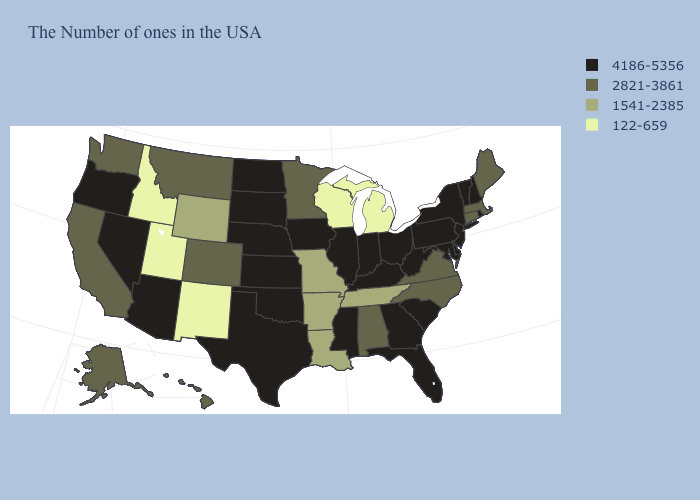Name the states that have a value in the range 122-659?
Write a very short answer. Michigan, Wisconsin, New Mexico, Utah, Idaho. Name the states that have a value in the range 1541-2385?
Give a very brief answer. Tennessee, Louisiana, Missouri, Arkansas, Wyoming. Name the states that have a value in the range 2821-3861?
Be succinct. Maine, Massachusetts, Connecticut, Virginia, North Carolina, Alabama, Minnesota, Colorado, Montana, California, Washington, Alaska, Hawaii. What is the highest value in the USA?
Answer briefly. 4186-5356. Which states have the highest value in the USA?
Quick response, please. Rhode Island, New Hampshire, Vermont, New York, New Jersey, Delaware, Maryland, Pennsylvania, South Carolina, West Virginia, Ohio, Florida, Georgia, Kentucky, Indiana, Illinois, Mississippi, Iowa, Kansas, Nebraska, Oklahoma, Texas, South Dakota, North Dakota, Arizona, Nevada, Oregon. How many symbols are there in the legend?
Answer briefly. 4. Does the map have missing data?
Short answer required. No. Does Pennsylvania have the same value as Utah?
Short answer required. No. How many symbols are there in the legend?
Be succinct. 4. What is the value of Hawaii?
Short answer required. 2821-3861. What is the value of Wisconsin?
Write a very short answer. 122-659. Name the states that have a value in the range 4186-5356?
Write a very short answer. Rhode Island, New Hampshire, Vermont, New York, New Jersey, Delaware, Maryland, Pennsylvania, South Carolina, West Virginia, Ohio, Florida, Georgia, Kentucky, Indiana, Illinois, Mississippi, Iowa, Kansas, Nebraska, Oklahoma, Texas, South Dakota, North Dakota, Arizona, Nevada, Oregon. Among the states that border Washington , does Idaho have the lowest value?
Short answer required. Yes. What is the value of Maine?
Be succinct. 2821-3861. Among the states that border Ohio , which have the highest value?
Quick response, please. Pennsylvania, West Virginia, Kentucky, Indiana. 